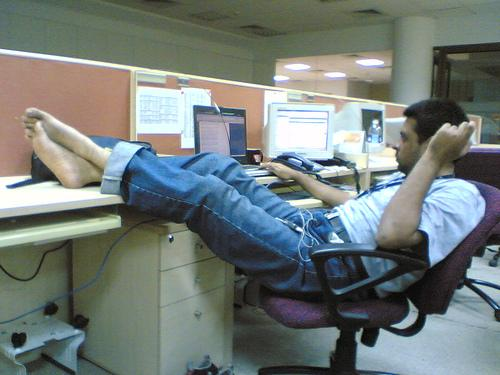Provide a detailed description of the man's clothing and accessories. The man is wearing a white shirt and blue jeans with rolled-up cuffs. He also has a blue lanyard around his neck. Analyze the sentiment of the image by referring to the man and his surroundings. The image conveys a laid-back and relaxed atmosphere, with the man lounging in his chair, bare feet on the desk, and engaging with electronic devices in a casual environment. Mention the objects pinned or attached to the wall. There are papers pinned on the board and more papers pinned to the wall behind the computer. Explain the man's posture and position while interacting with the electronic devices. The man sits on a reclined chair with his bare feet resting on the desk while his hands are occupied typing on a white keyboard, indicating a casual and relaxed working environment. Identify the objects that are placed on the desk. Laptop computer, black phone, cellphone, water bottle, and a keyboard. In a formal tone, describe the overall scene in the image. The image depicts a man wearing a white shirt and jeans, seated on a reclined swivel chair with his bare feet on the desk. The man is engaging with various electronic devices, such as a keyboard, laptop, cellphone, and monitors. Additionally, there are items resting on the desk and papers attached to the wall and a board. Count the number of electronic devices on the desk. 3 monitors, 1 cellphone, 1 black phone, and 1 laptop computer. In conversational language, describe the man's interaction with the desk in the image. The dude is kinda chilling on a reclined chair with his bare feet up on the desk, typing on a white keyboard, and surrounded by electronic gadgets. Create a caption detailing the man's action and appearance in the image. Man with bare feet wearing a white shirt and blue jeans, sitting on a reclined swivel chair, typing on a white keyboard with legs on the desk. Describe the chair the man is sitting on and its features. The man is sitting on a reclined swivel chair with a purple seat, black armrest, and black handle. 